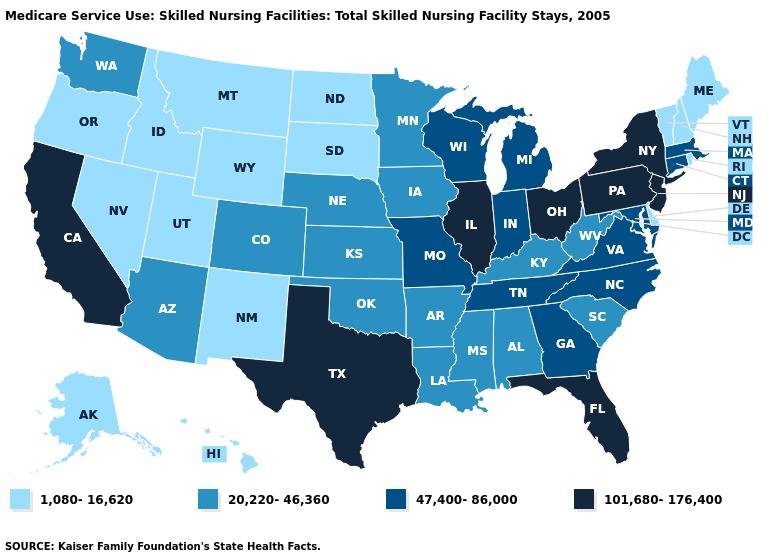Name the states that have a value in the range 47,400-86,000?
Be succinct. Connecticut, Georgia, Indiana, Maryland, Massachusetts, Michigan, Missouri, North Carolina, Tennessee, Virginia, Wisconsin. Among the states that border Michigan , which have the lowest value?
Give a very brief answer. Indiana, Wisconsin. Name the states that have a value in the range 20,220-46,360?
Write a very short answer. Alabama, Arizona, Arkansas, Colorado, Iowa, Kansas, Kentucky, Louisiana, Minnesota, Mississippi, Nebraska, Oklahoma, South Carolina, Washington, West Virginia. What is the value of Colorado?
Concise answer only. 20,220-46,360. What is the lowest value in states that border Florida?
Short answer required. 20,220-46,360. How many symbols are there in the legend?
Quick response, please. 4. What is the value of Massachusetts?
Short answer required. 47,400-86,000. Which states have the lowest value in the USA?
Be succinct. Alaska, Delaware, Hawaii, Idaho, Maine, Montana, Nevada, New Hampshire, New Mexico, North Dakota, Oregon, Rhode Island, South Dakota, Utah, Vermont, Wyoming. What is the value of Illinois?
Keep it brief. 101,680-176,400. What is the highest value in the USA?
Concise answer only. 101,680-176,400. Among the states that border Georgia , which have the highest value?
Short answer required. Florida. Among the states that border Alabama , does Florida have the highest value?
Write a very short answer. Yes. Name the states that have a value in the range 47,400-86,000?
Be succinct. Connecticut, Georgia, Indiana, Maryland, Massachusetts, Michigan, Missouri, North Carolina, Tennessee, Virginia, Wisconsin. Does the first symbol in the legend represent the smallest category?
Answer briefly. Yes. Does Vermont have the lowest value in the USA?
Answer briefly. Yes. 